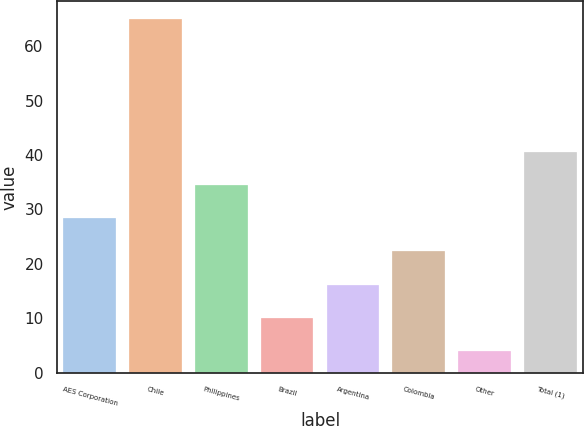Convert chart to OTSL. <chart><loc_0><loc_0><loc_500><loc_500><bar_chart><fcel>AES Corporation<fcel>Chile<fcel>Philippines<fcel>Brazil<fcel>Argentina<fcel>Colombia<fcel>Other<fcel>Total (1)<nl><fcel>28.4<fcel>65<fcel>34.5<fcel>10.1<fcel>16.2<fcel>22.3<fcel>4<fcel>40.6<nl></chart> 